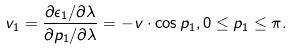Convert formula to latex. <formula><loc_0><loc_0><loc_500><loc_500>v _ { 1 } = \frac { \partial \epsilon _ { 1 } / \partial \lambda } { \partial p _ { 1 } / \partial \lambda } = - v \cdot \cos p _ { 1 } , 0 \leq p _ { 1 } \leq \pi .</formula> 